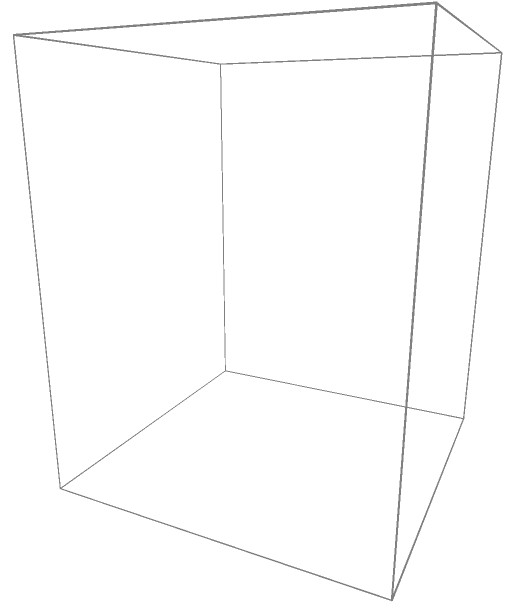A property developer plans to install a cylindrical water tank on top of a 20-meter tall building in NYC. The tank has a radius of 5 meters and a height of 10 meters. To comply with local regulations, the developer must paint the entire external surface of the tank, including the top and bottom. Calculate the total surface area that needs to be painted, in square meters. Round your answer to the nearest whole number. To solve this problem, we need to calculate the surface area of a cylinder, which includes the lateral surface area and the areas of the top and bottom circular bases.

Step 1: Calculate the lateral surface area of the cylinder.
Lateral surface area = $2\pi rh$
where $r$ is the radius and $h$ is the height.
Lateral surface area = $2\pi \cdot 5 \text{ m} \cdot 10 \text{ m} = 100\pi \text{ m}^2$

Step 2: Calculate the area of one circular base.
Area of circular base = $\pi r^2$
Area of circular base = $\pi \cdot (5 \text{ m})^2 = 25\pi \text{ m}^2$

Step 3: Calculate the total surface area by adding the lateral surface area and the areas of both circular bases.
Total surface area = Lateral surface area + 2 * Area of circular base
Total surface area = $100\pi \text{ m}^2 + 2 \cdot 25\pi \text{ m}^2 = 150\pi \text{ m}^2$

Step 4: Convert the result to a numeric value and round to the nearest whole number.
Total surface area ≈ 471 m²
Answer: 471 m² 